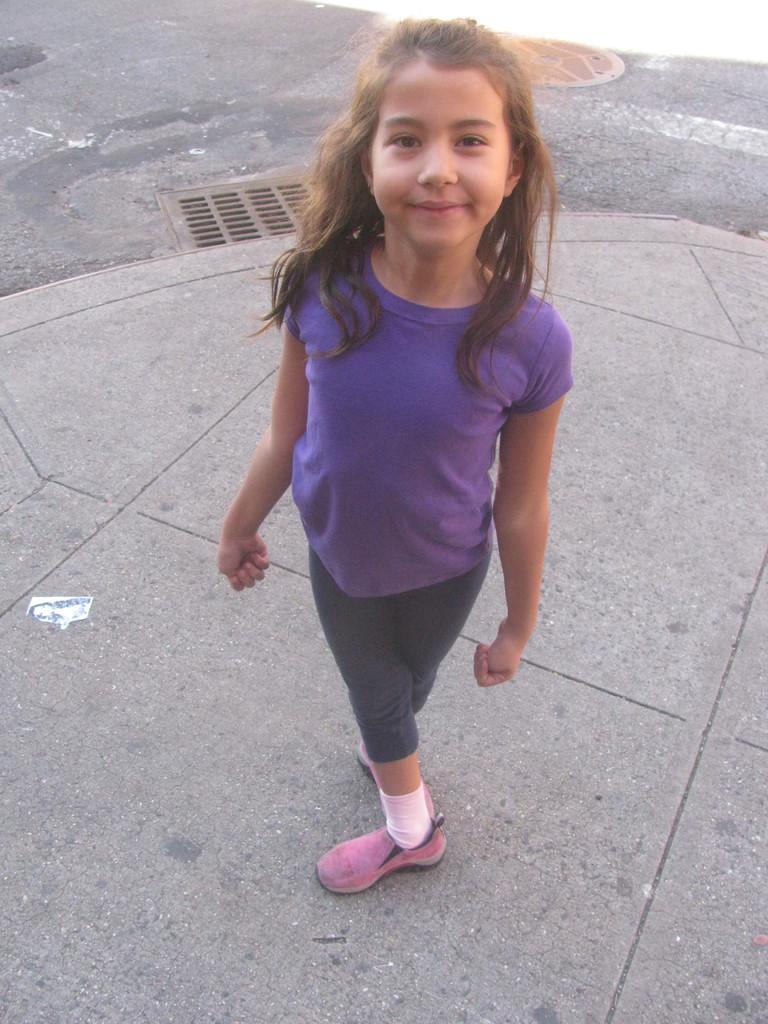How would you summarize this image in a sentence or two? In this picture there is a girl standing and smiling. At the back it looks like a manhole on the road. 